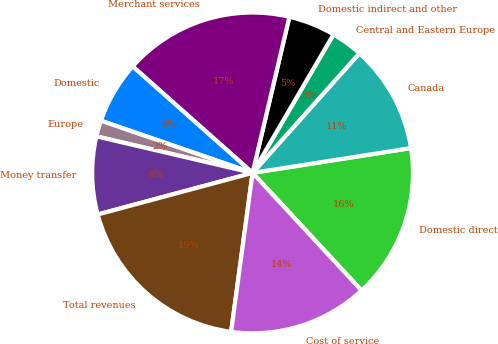Convert chart. <chart><loc_0><loc_0><loc_500><loc_500><pie_chart><fcel>Domestic direct<fcel>Canada<fcel>Central and Eastern Europe<fcel>Domestic indirect and other<fcel>Merchant services<fcel>Domestic<fcel>Europe<fcel>Money transfer<fcel>Total revenues<fcel>Cost of service<nl><fcel>15.58%<fcel>10.93%<fcel>3.18%<fcel>4.73%<fcel>17.13%<fcel>6.28%<fcel>1.62%<fcel>7.83%<fcel>18.69%<fcel>14.03%<nl></chart> 